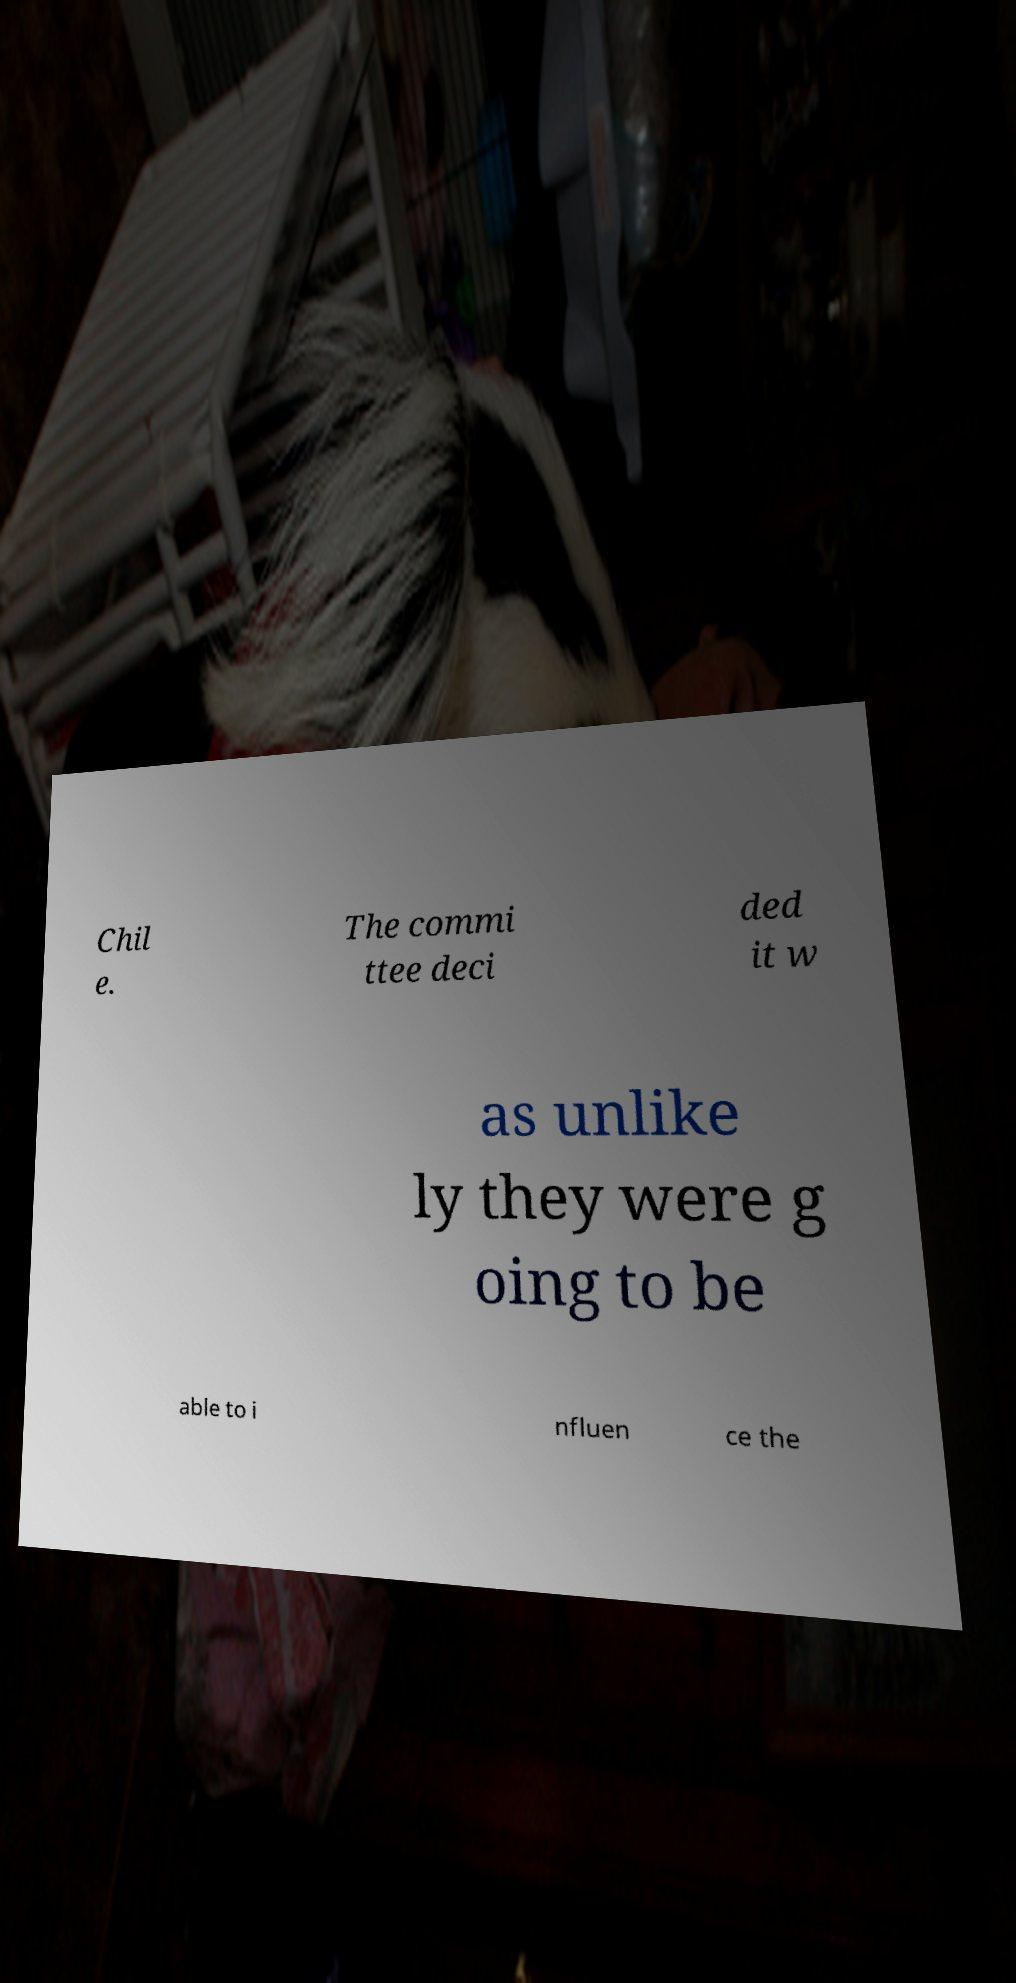For documentation purposes, I need the text within this image transcribed. Could you provide that? Chil e. The commi ttee deci ded it w as unlike ly they were g oing to be able to i nfluen ce the 